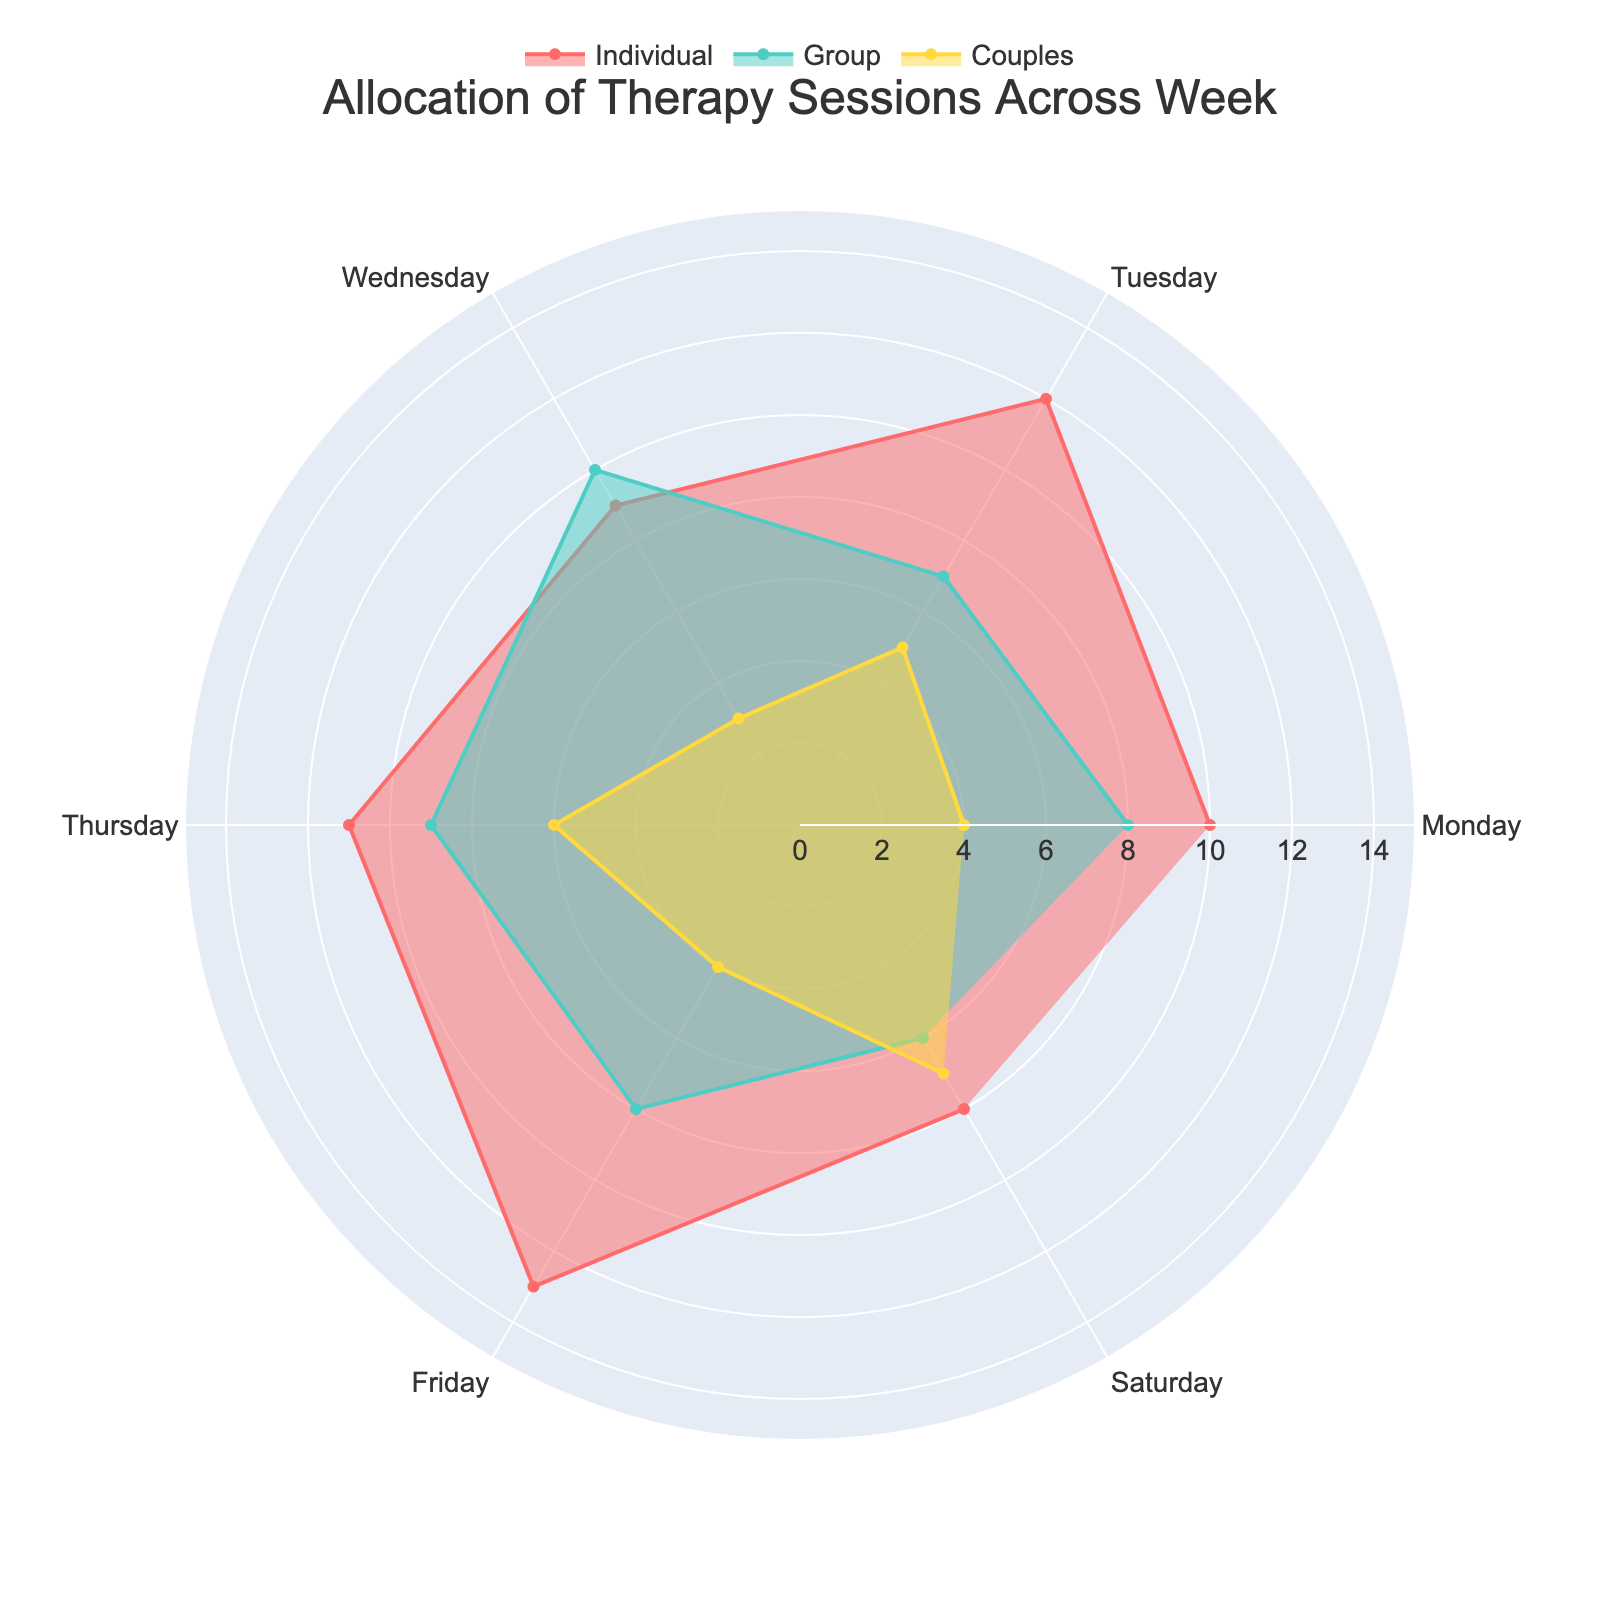What's the title of the chart? The title is usually located at the top of the chart and is meant to provide a brief overview of the chart's subject. For this chart, we can see it states: "Allocation of Therapy Sessions Across Week".
Answer: Allocation of Therapy Sessions Across Week Which type of therapy has the highest number of sessions on Tuesday? Look at the lengths of the three radii (Individual, Group, Couples) for Tuesday. The individual sessions radius is the longest, followed by couples and then group sessions.
Answer: Individual Therapy On which day are the Group Therapy sessions at their maximum? Identify the longest radius for Group Therapy, represented by green lines and fill, and see which day it corresponds to. The longest radius is on Wednesday.
Answer: Wednesday How many total individual therapy sessions are there from Monday to Friday? Sum the radii lengths for Individual Therapy sessions from Monday to Friday: 10 (Monday) + 12 (Tuesday) + 9 (Wednesday) + 11 (Thursday) + 13 (Friday).
Answer: 55 Compare the number of Couples Therapy sessions on Wednesday versus Saturday. Which day has more? Look at the radii lengths for Couples Therapy on Wednesday and Saturday: Wednesday has 3 sessions, while Saturday has 7 sessions.
Answer: Saturday Which type of therapy has the most constant amount of sessions throughout the week? Evaluate the consistency of radii lengths for each therapy type across all days. Group Therapy (green) appears more consistent in length compared to the others.
Answer: Group Therapy Identify the day with the least number of total therapy sessions. Sum the number of sessions for all three therapy types for each day:  
Monday (10 + 8 + 4),  
Tuesday (12 + 7 + 5),  
Wednesday (9 + 10 + 3),  
Thursday (11 + 9 + 6),  
Friday (13 + 8 + 4),  
Saturday (8 + 6 + 7).  
The day with the smallest sum is Wednesday (22).
Answer: Wednesday Is the number of Couples Therapy sessions on Thursday the same as on Monday? Locate the radii lengths for Couples Therapy on both Thursday and Monday; both have the same length representing 4 sessions each.
Answer: Yes What is the difference between the maximum and minimum number of Individual Therapy sessions in the week? Identify the highest and lowest radii lengths for Individual Therapy: Maximum is 13 (Friday), and minimum is 8 (Saturday). The difference is 13 - 8.
Answer: 5 